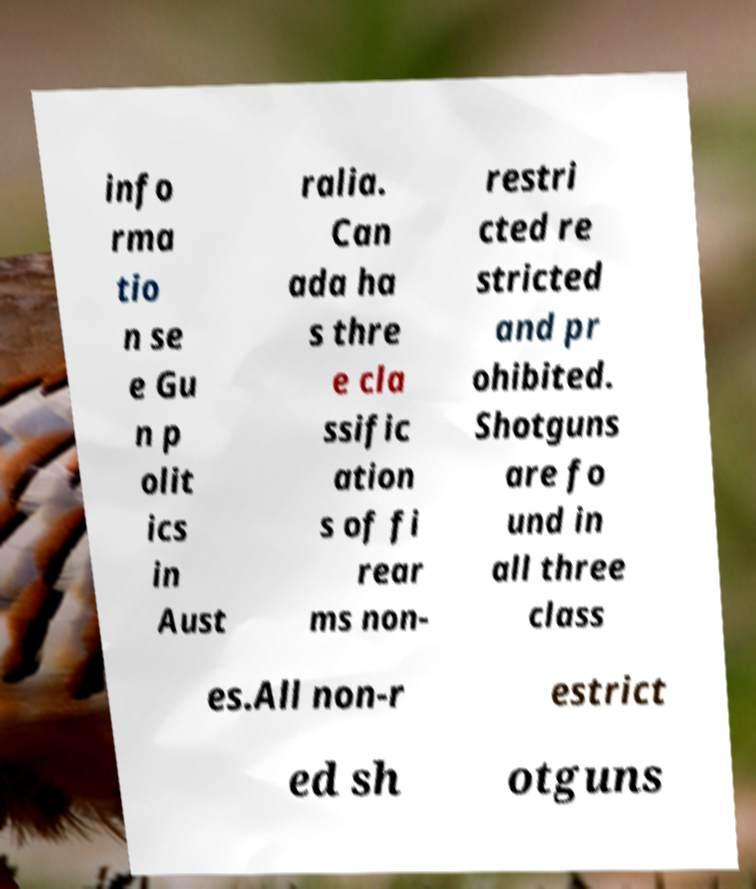Can you read and provide the text displayed in the image?This photo seems to have some interesting text. Can you extract and type it out for me? info rma tio n se e Gu n p olit ics in Aust ralia. Can ada ha s thre e cla ssific ation s of fi rear ms non- restri cted re stricted and pr ohibited. Shotguns are fo und in all three class es.All non-r estrict ed sh otguns 